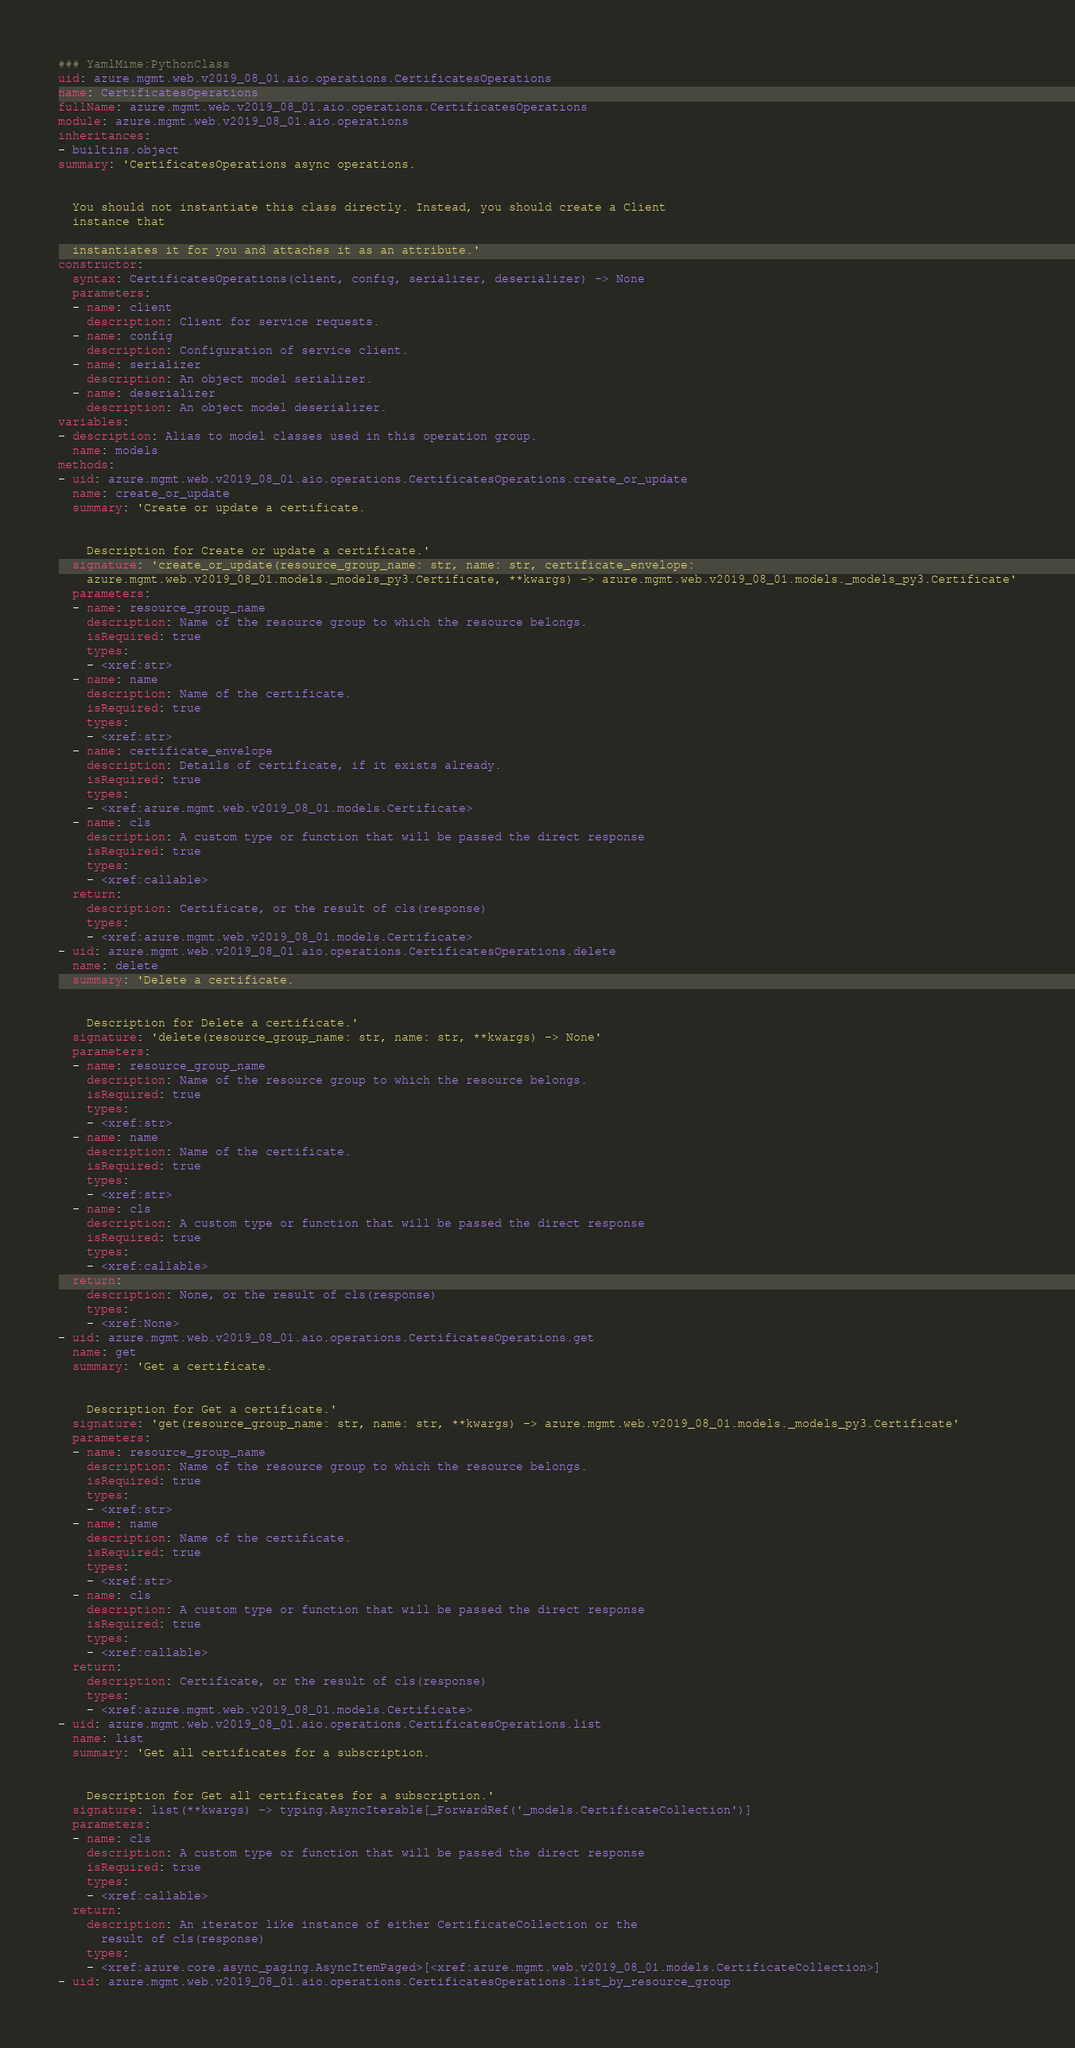Convert code to text. <code><loc_0><loc_0><loc_500><loc_500><_YAML_>### YamlMime:PythonClass
uid: azure.mgmt.web.v2019_08_01.aio.operations.CertificatesOperations
name: CertificatesOperations
fullName: azure.mgmt.web.v2019_08_01.aio.operations.CertificatesOperations
module: azure.mgmt.web.v2019_08_01.aio.operations
inheritances:
- builtins.object
summary: 'CertificatesOperations async operations.


  You should not instantiate this class directly. Instead, you should create a Client
  instance that

  instantiates it for you and attaches it as an attribute.'
constructor:
  syntax: CertificatesOperations(client, config, serializer, deserializer) -> None
  parameters:
  - name: client
    description: Client for service requests.
  - name: config
    description: Configuration of service client.
  - name: serializer
    description: An object model serializer.
  - name: deserializer
    description: An object model deserializer.
variables:
- description: Alias to model classes used in this operation group.
  name: models
methods:
- uid: azure.mgmt.web.v2019_08_01.aio.operations.CertificatesOperations.create_or_update
  name: create_or_update
  summary: 'Create or update a certificate.


    Description for Create or update a certificate.'
  signature: 'create_or_update(resource_group_name: str, name: str, certificate_envelope:
    azure.mgmt.web.v2019_08_01.models._models_py3.Certificate, **kwargs) -> azure.mgmt.web.v2019_08_01.models._models_py3.Certificate'
  parameters:
  - name: resource_group_name
    description: Name of the resource group to which the resource belongs.
    isRequired: true
    types:
    - <xref:str>
  - name: name
    description: Name of the certificate.
    isRequired: true
    types:
    - <xref:str>
  - name: certificate_envelope
    description: Details of certificate, if it exists already.
    isRequired: true
    types:
    - <xref:azure.mgmt.web.v2019_08_01.models.Certificate>
  - name: cls
    description: A custom type or function that will be passed the direct response
    isRequired: true
    types:
    - <xref:callable>
  return:
    description: Certificate, or the result of cls(response)
    types:
    - <xref:azure.mgmt.web.v2019_08_01.models.Certificate>
- uid: azure.mgmt.web.v2019_08_01.aio.operations.CertificatesOperations.delete
  name: delete
  summary: 'Delete a certificate.


    Description for Delete a certificate.'
  signature: 'delete(resource_group_name: str, name: str, **kwargs) -> None'
  parameters:
  - name: resource_group_name
    description: Name of the resource group to which the resource belongs.
    isRequired: true
    types:
    - <xref:str>
  - name: name
    description: Name of the certificate.
    isRequired: true
    types:
    - <xref:str>
  - name: cls
    description: A custom type or function that will be passed the direct response
    isRequired: true
    types:
    - <xref:callable>
  return:
    description: None, or the result of cls(response)
    types:
    - <xref:None>
- uid: azure.mgmt.web.v2019_08_01.aio.operations.CertificatesOperations.get
  name: get
  summary: 'Get a certificate.


    Description for Get a certificate.'
  signature: 'get(resource_group_name: str, name: str, **kwargs) -> azure.mgmt.web.v2019_08_01.models._models_py3.Certificate'
  parameters:
  - name: resource_group_name
    description: Name of the resource group to which the resource belongs.
    isRequired: true
    types:
    - <xref:str>
  - name: name
    description: Name of the certificate.
    isRequired: true
    types:
    - <xref:str>
  - name: cls
    description: A custom type or function that will be passed the direct response
    isRequired: true
    types:
    - <xref:callable>
  return:
    description: Certificate, or the result of cls(response)
    types:
    - <xref:azure.mgmt.web.v2019_08_01.models.Certificate>
- uid: azure.mgmt.web.v2019_08_01.aio.operations.CertificatesOperations.list
  name: list
  summary: 'Get all certificates for a subscription.


    Description for Get all certificates for a subscription.'
  signature: list(**kwargs) -> typing.AsyncIterable[_ForwardRef('_models.CertificateCollection')]
  parameters:
  - name: cls
    description: A custom type or function that will be passed the direct response
    isRequired: true
    types:
    - <xref:callable>
  return:
    description: An iterator like instance of either CertificateCollection or the
      result of cls(response)
    types:
    - <xref:azure.core.async_paging.AsyncItemPaged>[<xref:azure.mgmt.web.v2019_08_01.models.CertificateCollection>]
- uid: azure.mgmt.web.v2019_08_01.aio.operations.CertificatesOperations.list_by_resource_group</code> 